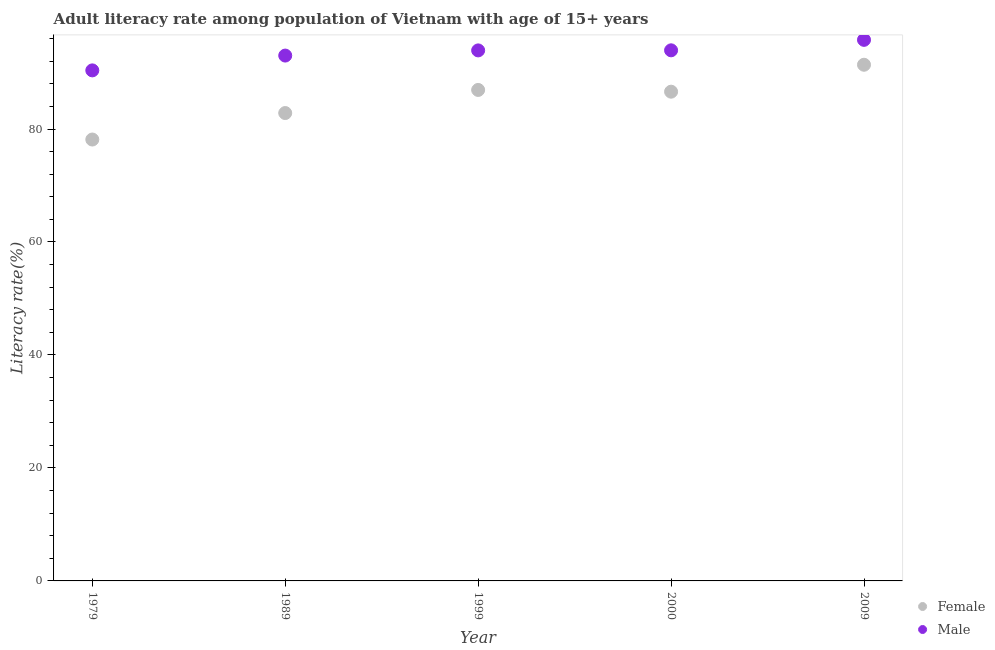How many different coloured dotlines are there?
Offer a terse response. 2. Is the number of dotlines equal to the number of legend labels?
Your response must be concise. Yes. What is the male adult literacy rate in 1979?
Your answer should be very brief. 90.38. Across all years, what is the maximum male adult literacy rate?
Your response must be concise. 95.79. Across all years, what is the minimum female adult literacy rate?
Offer a very short reply. 78.14. In which year was the male adult literacy rate minimum?
Keep it short and to the point. 1979. What is the total male adult literacy rate in the graph?
Offer a terse response. 467.02. What is the difference between the female adult literacy rate in 1999 and that in 2000?
Offer a very short reply. 0.31. What is the difference between the female adult literacy rate in 1979 and the male adult literacy rate in 2000?
Your response must be concise. -15.79. What is the average male adult literacy rate per year?
Make the answer very short. 93.4. In the year 2000, what is the difference between the female adult literacy rate and male adult literacy rate?
Your answer should be compact. -7.32. In how many years, is the male adult literacy rate greater than 68 %?
Provide a short and direct response. 5. What is the ratio of the male adult literacy rate in 1979 to that in 1989?
Make the answer very short. 0.97. Is the difference between the female adult literacy rate in 1979 and 2009 greater than the difference between the male adult literacy rate in 1979 and 2009?
Your answer should be compact. No. What is the difference between the highest and the second highest female adult literacy rate?
Keep it short and to the point. 4.46. What is the difference between the highest and the lowest male adult literacy rate?
Make the answer very short. 5.4. In how many years, is the female adult literacy rate greater than the average female adult literacy rate taken over all years?
Offer a terse response. 3. Is the sum of the female adult literacy rate in 1979 and 2000 greater than the maximum male adult literacy rate across all years?
Provide a succinct answer. Yes. How many years are there in the graph?
Offer a very short reply. 5. How are the legend labels stacked?
Your answer should be very brief. Vertical. What is the title of the graph?
Offer a terse response. Adult literacy rate among population of Vietnam with age of 15+ years. What is the label or title of the X-axis?
Keep it short and to the point. Year. What is the label or title of the Y-axis?
Keep it short and to the point. Literacy rate(%). What is the Literacy rate(%) in Female in 1979?
Make the answer very short. 78.14. What is the Literacy rate(%) of Male in 1979?
Offer a terse response. 90.38. What is the Literacy rate(%) in Female in 1989?
Offer a terse response. 82.83. What is the Literacy rate(%) of Male in 1989?
Ensure brevity in your answer.  93. What is the Literacy rate(%) of Female in 1999?
Make the answer very short. 86.92. What is the Literacy rate(%) in Male in 1999?
Offer a terse response. 93.92. What is the Literacy rate(%) of Female in 2000?
Ensure brevity in your answer.  86.61. What is the Literacy rate(%) in Male in 2000?
Offer a terse response. 93.93. What is the Literacy rate(%) in Female in 2009?
Provide a succinct answer. 91.38. What is the Literacy rate(%) of Male in 2009?
Keep it short and to the point. 95.79. Across all years, what is the maximum Literacy rate(%) of Female?
Your answer should be very brief. 91.38. Across all years, what is the maximum Literacy rate(%) in Male?
Your answer should be very brief. 95.79. Across all years, what is the minimum Literacy rate(%) in Female?
Offer a terse response. 78.14. Across all years, what is the minimum Literacy rate(%) of Male?
Give a very brief answer. 90.38. What is the total Literacy rate(%) in Female in the graph?
Give a very brief answer. 425.88. What is the total Literacy rate(%) in Male in the graph?
Your answer should be very brief. 467.02. What is the difference between the Literacy rate(%) in Female in 1979 and that in 1989?
Give a very brief answer. -4.69. What is the difference between the Literacy rate(%) of Male in 1979 and that in 1989?
Make the answer very short. -2.62. What is the difference between the Literacy rate(%) of Female in 1979 and that in 1999?
Offer a terse response. -8.78. What is the difference between the Literacy rate(%) of Male in 1979 and that in 1999?
Keep it short and to the point. -3.54. What is the difference between the Literacy rate(%) in Female in 1979 and that in 2000?
Keep it short and to the point. -8.47. What is the difference between the Literacy rate(%) of Male in 1979 and that in 2000?
Give a very brief answer. -3.55. What is the difference between the Literacy rate(%) in Female in 1979 and that in 2009?
Your response must be concise. -13.24. What is the difference between the Literacy rate(%) of Male in 1979 and that in 2009?
Make the answer very short. -5.4. What is the difference between the Literacy rate(%) of Female in 1989 and that in 1999?
Your response must be concise. -4.09. What is the difference between the Literacy rate(%) in Male in 1989 and that in 1999?
Offer a very short reply. -0.92. What is the difference between the Literacy rate(%) of Female in 1989 and that in 2000?
Offer a very short reply. -3.78. What is the difference between the Literacy rate(%) in Male in 1989 and that in 2000?
Make the answer very short. -0.93. What is the difference between the Literacy rate(%) in Female in 1989 and that in 2009?
Provide a short and direct response. -8.55. What is the difference between the Literacy rate(%) in Male in 1989 and that in 2009?
Make the answer very short. -2.78. What is the difference between the Literacy rate(%) of Female in 1999 and that in 2000?
Offer a very short reply. 0.31. What is the difference between the Literacy rate(%) in Male in 1999 and that in 2000?
Keep it short and to the point. -0.01. What is the difference between the Literacy rate(%) in Female in 1999 and that in 2009?
Your answer should be very brief. -4.46. What is the difference between the Literacy rate(%) of Male in 1999 and that in 2009?
Offer a very short reply. -1.87. What is the difference between the Literacy rate(%) of Female in 2000 and that in 2009?
Offer a terse response. -4.77. What is the difference between the Literacy rate(%) of Male in 2000 and that in 2009?
Your response must be concise. -1.85. What is the difference between the Literacy rate(%) of Female in 1979 and the Literacy rate(%) of Male in 1989?
Give a very brief answer. -14.86. What is the difference between the Literacy rate(%) in Female in 1979 and the Literacy rate(%) in Male in 1999?
Offer a terse response. -15.78. What is the difference between the Literacy rate(%) in Female in 1979 and the Literacy rate(%) in Male in 2000?
Provide a short and direct response. -15.79. What is the difference between the Literacy rate(%) in Female in 1979 and the Literacy rate(%) in Male in 2009?
Provide a short and direct response. -17.64. What is the difference between the Literacy rate(%) in Female in 1989 and the Literacy rate(%) in Male in 1999?
Offer a very short reply. -11.09. What is the difference between the Literacy rate(%) in Female in 1989 and the Literacy rate(%) in Male in 2000?
Keep it short and to the point. -11.1. What is the difference between the Literacy rate(%) in Female in 1989 and the Literacy rate(%) in Male in 2009?
Make the answer very short. -12.96. What is the difference between the Literacy rate(%) of Female in 1999 and the Literacy rate(%) of Male in 2000?
Give a very brief answer. -7.01. What is the difference between the Literacy rate(%) of Female in 1999 and the Literacy rate(%) of Male in 2009?
Provide a short and direct response. -8.87. What is the difference between the Literacy rate(%) of Female in 2000 and the Literacy rate(%) of Male in 2009?
Provide a short and direct response. -9.18. What is the average Literacy rate(%) of Female per year?
Offer a terse response. 85.18. What is the average Literacy rate(%) of Male per year?
Make the answer very short. 93.4. In the year 1979, what is the difference between the Literacy rate(%) of Female and Literacy rate(%) of Male?
Your answer should be compact. -12.24. In the year 1989, what is the difference between the Literacy rate(%) of Female and Literacy rate(%) of Male?
Offer a terse response. -10.17. In the year 1999, what is the difference between the Literacy rate(%) of Female and Literacy rate(%) of Male?
Offer a terse response. -7. In the year 2000, what is the difference between the Literacy rate(%) of Female and Literacy rate(%) of Male?
Make the answer very short. -7.32. In the year 2009, what is the difference between the Literacy rate(%) of Female and Literacy rate(%) of Male?
Provide a short and direct response. -4.41. What is the ratio of the Literacy rate(%) of Female in 1979 to that in 1989?
Your answer should be compact. 0.94. What is the ratio of the Literacy rate(%) in Male in 1979 to that in 1989?
Ensure brevity in your answer.  0.97. What is the ratio of the Literacy rate(%) of Female in 1979 to that in 1999?
Provide a short and direct response. 0.9. What is the ratio of the Literacy rate(%) in Male in 1979 to that in 1999?
Your answer should be compact. 0.96. What is the ratio of the Literacy rate(%) of Female in 1979 to that in 2000?
Offer a very short reply. 0.9. What is the ratio of the Literacy rate(%) in Male in 1979 to that in 2000?
Provide a short and direct response. 0.96. What is the ratio of the Literacy rate(%) of Female in 1979 to that in 2009?
Your response must be concise. 0.86. What is the ratio of the Literacy rate(%) of Male in 1979 to that in 2009?
Provide a succinct answer. 0.94. What is the ratio of the Literacy rate(%) in Female in 1989 to that in 1999?
Make the answer very short. 0.95. What is the ratio of the Literacy rate(%) in Male in 1989 to that in 1999?
Offer a very short reply. 0.99. What is the ratio of the Literacy rate(%) of Female in 1989 to that in 2000?
Ensure brevity in your answer.  0.96. What is the ratio of the Literacy rate(%) in Female in 1989 to that in 2009?
Provide a succinct answer. 0.91. What is the ratio of the Literacy rate(%) in Male in 1999 to that in 2000?
Provide a succinct answer. 1. What is the ratio of the Literacy rate(%) in Female in 1999 to that in 2009?
Offer a terse response. 0.95. What is the ratio of the Literacy rate(%) in Male in 1999 to that in 2009?
Keep it short and to the point. 0.98. What is the ratio of the Literacy rate(%) of Female in 2000 to that in 2009?
Make the answer very short. 0.95. What is the ratio of the Literacy rate(%) in Male in 2000 to that in 2009?
Make the answer very short. 0.98. What is the difference between the highest and the second highest Literacy rate(%) in Female?
Your response must be concise. 4.46. What is the difference between the highest and the second highest Literacy rate(%) in Male?
Your answer should be compact. 1.85. What is the difference between the highest and the lowest Literacy rate(%) in Female?
Make the answer very short. 13.24. What is the difference between the highest and the lowest Literacy rate(%) in Male?
Offer a very short reply. 5.4. 